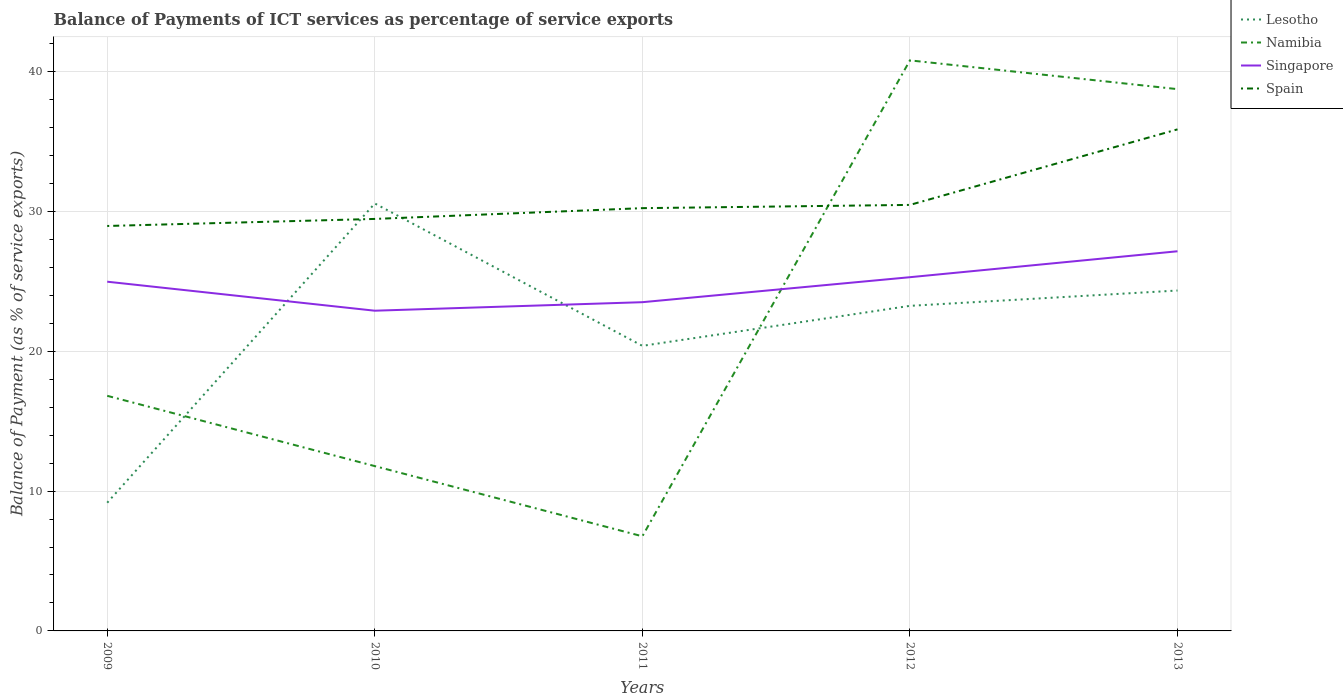How many different coloured lines are there?
Offer a terse response. 4. Does the line corresponding to Namibia intersect with the line corresponding to Singapore?
Make the answer very short. Yes. Across all years, what is the maximum balance of payments of ICT services in Lesotho?
Offer a terse response. 9.17. In which year was the balance of payments of ICT services in Lesotho maximum?
Ensure brevity in your answer.  2009. What is the total balance of payments of ICT services in Spain in the graph?
Keep it short and to the point. -1.51. What is the difference between the highest and the second highest balance of payments of ICT services in Lesotho?
Make the answer very short. 21.4. What is the difference between the highest and the lowest balance of payments of ICT services in Spain?
Make the answer very short. 1. How many lines are there?
Provide a short and direct response. 4. Are the values on the major ticks of Y-axis written in scientific E-notation?
Your answer should be very brief. No. How many legend labels are there?
Offer a terse response. 4. How are the legend labels stacked?
Keep it short and to the point. Vertical. What is the title of the graph?
Offer a terse response. Balance of Payments of ICT services as percentage of service exports. What is the label or title of the X-axis?
Offer a terse response. Years. What is the label or title of the Y-axis?
Your response must be concise. Balance of Payment (as % of service exports). What is the Balance of Payment (as % of service exports) in Lesotho in 2009?
Offer a terse response. 9.17. What is the Balance of Payment (as % of service exports) of Namibia in 2009?
Ensure brevity in your answer.  16.81. What is the Balance of Payment (as % of service exports) of Singapore in 2009?
Give a very brief answer. 24.97. What is the Balance of Payment (as % of service exports) in Spain in 2009?
Offer a very short reply. 28.95. What is the Balance of Payment (as % of service exports) of Lesotho in 2010?
Your answer should be compact. 30.56. What is the Balance of Payment (as % of service exports) in Namibia in 2010?
Ensure brevity in your answer.  11.78. What is the Balance of Payment (as % of service exports) in Singapore in 2010?
Give a very brief answer. 22.9. What is the Balance of Payment (as % of service exports) of Spain in 2010?
Provide a succinct answer. 29.46. What is the Balance of Payment (as % of service exports) of Lesotho in 2011?
Make the answer very short. 20.38. What is the Balance of Payment (as % of service exports) of Namibia in 2011?
Give a very brief answer. 6.77. What is the Balance of Payment (as % of service exports) of Singapore in 2011?
Offer a very short reply. 23.5. What is the Balance of Payment (as % of service exports) in Spain in 2011?
Provide a short and direct response. 30.23. What is the Balance of Payment (as % of service exports) in Lesotho in 2012?
Provide a succinct answer. 23.24. What is the Balance of Payment (as % of service exports) of Namibia in 2012?
Your answer should be compact. 40.79. What is the Balance of Payment (as % of service exports) in Singapore in 2012?
Keep it short and to the point. 25.29. What is the Balance of Payment (as % of service exports) of Spain in 2012?
Offer a terse response. 30.46. What is the Balance of Payment (as % of service exports) in Lesotho in 2013?
Give a very brief answer. 24.34. What is the Balance of Payment (as % of service exports) in Namibia in 2013?
Your answer should be compact. 38.74. What is the Balance of Payment (as % of service exports) of Singapore in 2013?
Your answer should be very brief. 27.15. What is the Balance of Payment (as % of service exports) in Spain in 2013?
Offer a very short reply. 35.86. Across all years, what is the maximum Balance of Payment (as % of service exports) in Lesotho?
Your answer should be very brief. 30.56. Across all years, what is the maximum Balance of Payment (as % of service exports) of Namibia?
Make the answer very short. 40.79. Across all years, what is the maximum Balance of Payment (as % of service exports) in Singapore?
Your answer should be very brief. 27.15. Across all years, what is the maximum Balance of Payment (as % of service exports) in Spain?
Your answer should be very brief. 35.86. Across all years, what is the minimum Balance of Payment (as % of service exports) in Lesotho?
Your answer should be compact. 9.17. Across all years, what is the minimum Balance of Payment (as % of service exports) of Namibia?
Provide a short and direct response. 6.77. Across all years, what is the minimum Balance of Payment (as % of service exports) in Singapore?
Your response must be concise. 22.9. Across all years, what is the minimum Balance of Payment (as % of service exports) in Spain?
Make the answer very short. 28.95. What is the total Balance of Payment (as % of service exports) in Lesotho in the graph?
Ensure brevity in your answer.  107.7. What is the total Balance of Payment (as % of service exports) in Namibia in the graph?
Your response must be concise. 114.89. What is the total Balance of Payment (as % of service exports) in Singapore in the graph?
Your response must be concise. 123.81. What is the total Balance of Payment (as % of service exports) in Spain in the graph?
Ensure brevity in your answer.  154.96. What is the difference between the Balance of Payment (as % of service exports) of Lesotho in 2009 and that in 2010?
Your response must be concise. -21.4. What is the difference between the Balance of Payment (as % of service exports) in Namibia in 2009 and that in 2010?
Keep it short and to the point. 5.03. What is the difference between the Balance of Payment (as % of service exports) of Singapore in 2009 and that in 2010?
Give a very brief answer. 2.07. What is the difference between the Balance of Payment (as % of service exports) of Spain in 2009 and that in 2010?
Make the answer very short. -0.5. What is the difference between the Balance of Payment (as % of service exports) in Lesotho in 2009 and that in 2011?
Ensure brevity in your answer.  -11.22. What is the difference between the Balance of Payment (as % of service exports) of Namibia in 2009 and that in 2011?
Offer a very short reply. 10.05. What is the difference between the Balance of Payment (as % of service exports) of Singapore in 2009 and that in 2011?
Your answer should be very brief. 1.47. What is the difference between the Balance of Payment (as % of service exports) of Spain in 2009 and that in 2011?
Provide a succinct answer. -1.27. What is the difference between the Balance of Payment (as % of service exports) of Lesotho in 2009 and that in 2012?
Provide a short and direct response. -14.08. What is the difference between the Balance of Payment (as % of service exports) in Namibia in 2009 and that in 2012?
Offer a terse response. -23.98. What is the difference between the Balance of Payment (as % of service exports) of Singapore in 2009 and that in 2012?
Give a very brief answer. -0.32. What is the difference between the Balance of Payment (as % of service exports) in Spain in 2009 and that in 2012?
Provide a short and direct response. -1.51. What is the difference between the Balance of Payment (as % of service exports) in Lesotho in 2009 and that in 2013?
Give a very brief answer. -15.17. What is the difference between the Balance of Payment (as % of service exports) of Namibia in 2009 and that in 2013?
Make the answer very short. -21.93. What is the difference between the Balance of Payment (as % of service exports) in Singapore in 2009 and that in 2013?
Provide a succinct answer. -2.18. What is the difference between the Balance of Payment (as % of service exports) of Spain in 2009 and that in 2013?
Keep it short and to the point. -6.91. What is the difference between the Balance of Payment (as % of service exports) of Lesotho in 2010 and that in 2011?
Offer a terse response. 10.18. What is the difference between the Balance of Payment (as % of service exports) of Namibia in 2010 and that in 2011?
Offer a terse response. 5.02. What is the difference between the Balance of Payment (as % of service exports) of Singapore in 2010 and that in 2011?
Your answer should be compact. -0.61. What is the difference between the Balance of Payment (as % of service exports) of Spain in 2010 and that in 2011?
Your response must be concise. -0.77. What is the difference between the Balance of Payment (as % of service exports) of Lesotho in 2010 and that in 2012?
Provide a short and direct response. 7.32. What is the difference between the Balance of Payment (as % of service exports) of Namibia in 2010 and that in 2012?
Give a very brief answer. -29.01. What is the difference between the Balance of Payment (as % of service exports) of Singapore in 2010 and that in 2012?
Give a very brief answer. -2.4. What is the difference between the Balance of Payment (as % of service exports) of Spain in 2010 and that in 2012?
Provide a succinct answer. -1. What is the difference between the Balance of Payment (as % of service exports) of Lesotho in 2010 and that in 2013?
Your answer should be compact. 6.22. What is the difference between the Balance of Payment (as % of service exports) of Namibia in 2010 and that in 2013?
Offer a terse response. -26.95. What is the difference between the Balance of Payment (as % of service exports) of Singapore in 2010 and that in 2013?
Your answer should be compact. -4.25. What is the difference between the Balance of Payment (as % of service exports) in Spain in 2010 and that in 2013?
Make the answer very short. -6.4. What is the difference between the Balance of Payment (as % of service exports) of Lesotho in 2011 and that in 2012?
Offer a very short reply. -2.86. What is the difference between the Balance of Payment (as % of service exports) in Namibia in 2011 and that in 2012?
Your response must be concise. -34.03. What is the difference between the Balance of Payment (as % of service exports) of Singapore in 2011 and that in 2012?
Make the answer very short. -1.79. What is the difference between the Balance of Payment (as % of service exports) in Spain in 2011 and that in 2012?
Give a very brief answer. -0.23. What is the difference between the Balance of Payment (as % of service exports) in Lesotho in 2011 and that in 2013?
Ensure brevity in your answer.  -3.96. What is the difference between the Balance of Payment (as % of service exports) in Namibia in 2011 and that in 2013?
Provide a succinct answer. -31.97. What is the difference between the Balance of Payment (as % of service exports) in Singapore in 2011 and that in 2013?
Your response must be concise. -3.64. What is the difference between the Balance of Payment (as % of service exports) of Spain in 2011 and that in 2013?
Provide a short and direct response. -5.63. What is the difference between the Balance of Payment (as % of service exports) of Lesotho in 2012 and that in 2013?
Ensure brevity in your answer.  -1.1. What is the difference between the Balance of Payment (as % of service exports) in Namibia in 2012 and that in 2013?
Your answer should be compact. 2.06. What is the difference between the Balance of Payment (as % of service exports) in Singapore in 2012 and that in 2013?
Make the answer very short. -1.85. What is the difference between the Balance of Payment (as % of service exports) in Spain in 2012 and that in 2013?
Make the answer very short. -5.4. What is the difference between the Balance of Payment (as % of service exports) of Lesotho in 2009 and the Balance of Payment (as % of service exports) of Namibia in 2010?
Give a very brief answer. -2.62. What is the difference between the Balance of Payment (as % of service exports) of Lesotho in 2009 and the Balance of Payment (as % of service exports) of Singapore in 2010?
Provide a short and direct response. -13.73. What is the difference between the Balance of Payment (as % of service exports) in Lesotho in 2009 and the Balance of Payment (as % of service exports) in Spain in 2010?
Provide a succinct answer. -20.29. What is the difference between the Balance of Payment (as % of service exports) of Namibia in 2009 and the Balance of Payment (as % of service exports) of Singapore in 2010?
Your answer should be compact. -6.08. What is the difference between the Balance of Payment (as % of service exports) of Namibia in 2009 and the Balance of Payment (as % of service exports) of Spain in 2010?
Offer a terse response. -12.65. What is the difference between the Balance of Payment (as % of service exports) in Singapore in 2009 and the Balance of Payment (as % of service exports) in Spain in 2010?
Keep it short and to the point. -4.49. What is the difference between the Balance of Payment (as % of service exports) of Lesotho in 2009 and the Balance of Payment (as % of service exports) of Namibia in 2011?
Offer a very short reply. 2.4. What is the difference between the Balance of Payment (as % of service exports) of Lesotho in 2009 and the Balance of Payment (as % of service exports) of Singapore in 2011?
Provide a succinct answer. -14.34. What is the difference between the Balance of Payment (as % of service exports) in Lesotho in 2009 and the Balance of Payment (as % of service exports) in Spain in 2011?
Ensure brevity in your answer.  -21.06. What is the difference between the Balance of Payment (as % of service exports) in Namibia in 2009 and the Balance of Payment (as % of service exports) in Singapore in 2011?
Ensure brevity in your answer.  -6.69. What is the difference between the Balance of Payment (as % of service exports) of Namibia in 2009 and the Balance of Payment (as % of service exports) of Spain in 2011?
Make the answer very short. -13.42. What is the difference between the Balance of Payment (as % of service exports) in Singapore in 2009 and the Balance of Payment (as % of service exports) in Spain in 2011?
Your answer should be compact. -5.26. What is the difference between the Balance of Payment (as % of service exports) in Lesotho in 2009 and the Balance of Payment (as % of service exports) in Namibia in 2012?
Your answer should be very brief. -31.63. What is the difference between the Balance of Payment (as % of service exports) in Lesotho in 2009 and the Balance of Payment (as % of service exports) in Singapore in 2012?
Keep it short and to the point. -16.13. What is the difference between the Balance of Payment (as % of service exports) in Lesotho in 2009 and the Balance of Payment (as % of service exports) in Spain in 2012?
Ensure brevity in your answer.  -21.29. What is the difference between the Balance of Payment (as % of service exports) in Namibia in 2009 and the Balance of Payment (as % of service exports) in Singapore in 2012?
Make the answer very short. -8.48. What is the difference between the Balance of Payment (as % of service exports) of Namibia in 2009 and the Balance of Payment (as % of service exports) of Spain in 2012?
Your answer should be very brief. -13.65. What is the difference between the Balance of Payment (as % of service exports) of Singapore in 2009 and the Balance of Payment (as % of service exports) of Spain in 2012?
Give a very brief answer. -5.49. What is the difference between the Balance of Payment (as % of service exports) of Lesotho in 2009 and the Balance of Payment (as % of service exports) of Namibia in 2013?
Your answer should be very brief. -29.57. What is the difference between the Balance of Payment (as % of service exports) in Lesotho in 2009 and the Balance of Payment (as % of service exports) in Singapore in 2013?
Your answer should be compact. -17.98. What is the difference between the Balance of Payment (as % of service exports) of Lesotho in 2009 and the Balance of Payment (as % of service exports) of Spain in 2013?
Your response must be concise. -26.7. What is the difference between the Balance of Payment (as % of service exports) in Namibia in 2009 and the Balance of Payment (as % of service exports) in Singapore in 2013?
Provide a succinct answer. -10.33. What is the difference between the Balance of Payment (as % of service exports) of Namibia in 2009 and the Balance of Payment (as % of service exports) of Spain in 2013?
Offer a terse response. -19.05. What is the difference between the Balance of Payment (as % of service exports) in Singapore in 2009 and the Balance of Payment (as % of service exports) in Spain in 2013?
Your answer should be very brief. -10.89. What is the difference between the Balance of Payment (as % of service exports) of Lesotho in 2010 and the Balance of Payment (as % of service exports) of Namibia in 2011?
Your answer should be very brief. 23.8. What is the difference between the Balance of Payment (as % of service exports) in Lesotho in 2010 and the Balance of Payment (as % of service exports) in Singapore in 2011?
Offer a terse response. 7.06. What is the difference between the Balance of Payment (as % of service exports) of Lesotho in 2010 and the Balance of Payment (as % of service exports) of Spain in 2011?
Give a very brief answer. 0.34. What is the difference between the Balance of Payment (as % of service exports) in Namibia in 2010 and the Balance of Payment (as % of service exports) in Singapore in 2011?
Make the answer very short. -11.72. What is the difference between the Balance of Payment (as % of service exports) of Namibia in 2010 and the Balance of Payment (as % of service exports) of Spain in 2011?
Give a very brief answer. -18.44. What is the difference between the Balance of Payment (as % of service exports) in Singapore in 2010 and the Balance of Payment (as % of service exports) in Spain in 2011?
Offer a terse response. -7.33. What is the difference between the Balance of Payment (as % of service exports) of Lesotho in 2010 and the Balance of Payment (as % of service exports) of Namibia in 2012?
Provide a succinct answer. -10.23. What is the difference between the Balance of Payment (as % of service exports) in Lesotho in 2010 and the Balance of Payment (as % of service exports) in Singapore in 2012?
Ensure brevity in your answer.  5.27. What is the difference between the Balance of Payment (as % of service exports) of Lesotho in 2010 and the Balance of Payment (as % of service exports) of Spain in 2012?
Ensure brevity in your answer.  0.1. What is the difference between the Balance of Payment (as % of service exports) in Namibia in 2010 and the Balance of Payment (as % of service exports) in Singapore in 2012?
Ensure brevity in your answer.  -13.51. What is the difference between the Balance of Payment (as % of service exports) of Namibia in 2010 and the Balance of Payment (as % of service exports) of Spain in 2012?
Offer a very short reply. -18.68. What is the difference between the Balance of Payment (as % of service exports) in Singapore in 2010 and the Balance of Payment (as % of service exports) in Spain in 2012?
Your response must be concise. -7.57. What is the difference between the Balance of Payment (as % of service exports) in Lesotho in 2010 and the Balance of Payment (as % of service exports) in Namibia in 2013?
Your answer should be compact. -8.17. What is the difference between the Balance of Payment (as % of service exports) of Lesotho in 2010 and the Balance of Payment (as % of service exports) of Singapore in 2013?
Make the answer very short. 3.42. What is the difference between the Balance of Payment (as % of service exports) of Lesotho in 2010 and the Balance of Payment (as % of service exports) of Spain in 2013?
Provide a short and direct response. -5.3. What is the difference between the Balance of Payment (as % of service exports) of Namibia in 2010 and the Balance of Payment (as % of service exports) of Singapore in 2013?
Keep it short and to the point. -15.36. What is the difference between the Balance of Payment (as % of service exports) in Namibia in 2010 and the Balance of Payment (as % of service exports) in Spain in 2013?
Give a very brief answer. -24.08. What is the difference between the Balance of Payment (as % of service exports) of Singapore in 2010 and the Balance of Payment (as % of service exports) of Spain in 2013?
Offer a terse response. -12.97. What is the difference between the Balance of Payment (as % of service exports) of Lesotho in 2011 and the Balance of Payment (as % of service exports) of Namibia in 2012?
Offer a terse response. -20.41. What is the difference between the Balance of Payment (as % of service exports) in Lesotho in 2011 and the Balance of Payment (as % of service exports) in Singapore in 2012?
Offer a very short reply. -4.91. What is the difference between the Balance of Payment (as % of service exports) in Lesotho in 2011 and the Balance of Payment (as % of service exports) in Spain in 2012?
Your response must be concise. -10.08. What is the difference between the Balance of Payment (as % of service exports) in Namibia in 2011 and the Balance of Payment (as % of service exports) in Singapore in 2012?
Give a very brief answer. -18.53. What is the difference between the Balance of Payment (as % of service exports) in Namibia in 2011 and the Balance of Payment (as % of service exports) in Spain in 2012?
Offer a terse response. -23.7. What is the difference between the Balance of Payment (as % of service exports) in Singapore in 2011 and the Balance of Payment (as % of service exports) in Spain in 2012?
Your answer should be very brief. -6.96. What is the difference between the Balance of Payment (as % of service exports) of Lesotho in 2011 and the Balance of Payment (as % of service exports) of Namibia in 2013?
Give a very brief answer. -18.35. What is the difference between the Balance of Payment (as % of service exports) in Lesotho in 2011 and the Balance of Payment (as % of service exports) in Singapore in 2013?
Make the answer very short. -6.76. What is the difference between the Balance of Payment (as % of service exports) of Lesotho in 2011 and the Balance of Payment (as % of service exports) of Spain in 2013?
Give a very brief answer. -15.48. What is the difference between the Balance of Payment (as % of service exports) in Namibia in 2011 and the Balance of Payment (as % of service exports) in Singapore in 2013?
Offer a very short reply. -20.38. What is the difference between the Balance of Payment (as % of service exports) of Namibia in 2011 and the Balance of Payment (as % of service exports) of Spain in 2013?
Give a very brief answer. -29.1. What is the difference between the Balance of Payment (as % of service exports) in Singapore in 2011 and the Balance of Payment (as % of service exports) in Spain in 2013?
Keep it short and to the point. -12.36. What is the difference between the Balance of Payment (as % of service exports) of Lesotho in 2012 and the Balance of Payment (as % of service exports) of Namibia in 2013?
Provide a short and direct response. -15.49. What is the difference between the Balance of Payment (as % of service exports) in Lesotho in 2012 and the Balance of Payment (as % of service exports) in Singapore in 2013?
Your response must be concise. -3.9. What is the difference between the Balance of Payment (as % of service exports) of Lesotho in 2012 and the Balance of Payment (as % of service exports) of Spain in 2013?
Your answer should be very brief. -12.62. What is the difference between the Balance of Payment (as % of service exports) in Namibia in 2012 and the Balance of Payment (as % of service exports) in Singapore in 2013?
Keep it short and to the point. 13.65. What is the difference between the Balance of Payment (as % of service exports) in Namibia in 2012 and the Balance of Payment (as % of service exports) in Spain in 2013?
Offer a very short reply. 4.93. What is the difference between the Balance of Payment (as % of service exports) of Singapore in 2012 and the Balance of Payment (as % of service exports) of Spain in 2013?
Keep it short and to the point. -10.57. What is the average Balance of Payment (as % of service exports) of Lesotho per year?
Offer a terse response. 21.54. What is the average Balance of Payment (as % of service exports) in Namibia per year?
Ensure brevity in your answer.  22.98. What is the average Balance of Payment (as % of service exports) in Singapore per year?
Offer a very short reply. 24.76. What is the average Balance of Payment (as % of service exports) in Spain per year?
Give a very brief answer. 30.99. In the year 2009, what is the difference between the Balance of Payment (as % of service exports) of Lesotho and Balance of Payment (as % of service exports) of Namibia?
Provide a short and direct response. -7.64. In the year 2009, what is the difference between the Balance of Payment (as % of service exports) of Lesotho and Balance of Payment (as % of service exports) of Singapore?
Offer a very short reply. -15.8. In the year 2009, what is the difference between the Balance of Payment (as % of service exports) in Lesotho and Balance of Payment (as % of service exports) in Spain?
Your response must be concise. -19.79. In the year 2009, what is the difference between the Balance of Payment (as % of service exports) of Namibia and Balance of Payment (as % of service exports) of Singapore?
Offer a very short reply. -8.16. In the year 2009, what is the difference between the Balance of Payment (as % of service exports) in Namibia and Balance of Payment (as % of service exports) in Spain?
Ensure brevity in your answer.  -12.14. In the year 2009, what is the difference between the Balance of Payment (as % of service exports) of Singapore and Balance of Payment (as % of service exports) of Spain?
Provide a short and direct response. -3.98. In the year 2010, what is the difference between the Balance of Payment (as % of service exports) of Lesotho and Balance of Payment (as % of service exports) of Namibia?
Keep it short and to the point. 18.78. In the year 2010, what is the difference between the Balance of Payment (as % of service exports) in Lesotho and Balance of Payment (as % of service exports) in Singapore?
Your response must be concise. 7.67. In the year 2010, what is the difference between the Balance of Payment (as % of service exports) in Lesotho and Balance of Payment (as % of service exports) in Spain?
Make the answer very short. 1.11. In the year 2010, what is the difference between the Balance of Payment (as % of service exports) of Namibia and Balance of Payment (as % of service exports) of Singapore?
Ensure brevity in your answer.  -11.11. In the year 2010, what is the difference between the Balance of Payment (as % of service exports) in Namibia and Balance of Payment (as % of service exports) in Spain?
Offer a terse response. -17.67. In the year 2010, what is the difference between the Balance of Payment (as % of service exports) in Singapore and Balance of Payment (as % of service exports) in Spain?
Offer a terse response. -6.56. In the year 2011, what is the difference between the Balance of Payment (as % of service exports) in Lesotho and Balance of Payment (as % of service exports) in Namibia?
Keep it short and to the point. 13.62. In the year 2011, what is the difference between the Balance of Payment (as % of service exports) of Lesotho and Balance of Payment (as % of service exports) of Singapore?
Your response must be concise. -3.12. In the year 2011, what is the difference between the Balance of Payment (as % of service exports) of Lesotho and Balance of Payment (as % of service exports) of Spain?
Your answer should be very brief. -9.85. In the year 2011, what is the difference between the Balance of Payment (as % of service exports) in Namibia and Balance of Payment (as % of service exports) in Singapore?
Keep it short and to the point. -16.74. In the year 2011, what is the difference between the Balance of Payment (as % of service exports) of Namibia and Balance of Payment (as % of service exports) of Spain?
Give a very brief answer. -23.46. In the year 2011, what is the difference between the Balance of Payment (as % of service exports) of Singapore and Balance of Payment (as % of service exports) of Spain?
Keep it short and to the point. -6.72. In the year 2012, what is the difference between the Balance of Payment (as % of service exports) of Lesotho and Balance of Payment (as % of service exports) of Namibia?
Make the answer very short. -17.55. In the year 2012, what is the difference between the Balance of Payment (as % of service exports) of Lesotho and Balance of Payment (as % of service exports) of Singapore?
Keep it short and to the point. -2.05. In the year 2012, what is the difference between the Balance of Payment (as % of service exports) in Lesotho and Balance of Payment (as % of service exports) in Spain?
Keep it short and to the point. -7.22. In the year 2012, what is the difference between the Balance of Payment (as % of service exports) in Namibia and Balance of Payment (as % of service exports) in Singapore?
Provide a succinct answer. 15.5. In the year 2012, what is the difference between the Balance of Payment (as % of service exports) of Namibia and Balance of Payment (as % of service exports) of Spain?
Offer a very short reply. 10.33. In the year 2012, what is the difference between the Balance of Payment (as % of service exports) in Singapore and Balance of Payment (as % of service exports) in Spain?
Give a very brief answer. -5.17. In the year 2013, what is the difference between the Balance of Payment (as % of service exports) of Lesotho and Balance of Payment (as % of service exports) of Namibia?
Your answer should be very brief. -14.4. In the year 2013, what is the difference between the Balance of Payment (as % of service exports) in Lesotho and Balance of Payment (as % of service exports) in Singapore?
Offer a terse response. -2.81. In the year 2013, what is the difference between the Balance of Payment (as % of service exports) of Lesotho and Balance of Payment (as % of service exports) of Spain?
Make the answer very short. -11.52. In the year 2013, what is the difference between the Balance of Payment (as % of service exports) in Namibia and Balance of Payment (as % of service exports) in Singapore?
Your answer should be very brief. 11.59. In the year 2013, what is the difference between the Balance of Payment (as % of service exports) of Namibia and Balance of Payment (as % of service exports) of Spain?
Provide a succinct answer. 2.88. In the year 2013, what is the difference between the Balance of Payment (as % of service exports) of Singapore and Balance of Payment (as % of service exports) of Spain?
Offer a very short reply. -8.72. What is the ratio of the Balance of Payment (as % of service exports) in Lesotho in 2009 to that in 2010?
Provide a short and direct response. 0.3. What is the ratio of the Balance of Payment (as % of service exports) in Namibia in 2009 to that in 2010?
Your answer should be compact. 1.43. What is the ratio of the Balance of Payment (as % of service exports) of Singapore in 2009 to that in 2010?
Your response must be concise. 1.09. What is the ratio of the Balance of Payment (as % of service exports) in Spain in 2009 to that in 2010?
Ensure brevity in your answer.  0.98. What is the ratio of the Balance of Payment (as % of service exports) in Lesotho in 2009 to that in 2011?
Give a very brief answer. 0.45. What is the ratio of the Balance of Payment (as % of service exports) of Namibia in 2009 to that in 2011?
Offer a very short reply. 2.48. What is the ratio of the Balance of Payment (as % of service exports) of Singapore in 2009 to that in 2011?
Offer a terse response. 1.06. What is the ratio of the Balance of Payment (as % of service exports) in Spain in 2009 to that in 2011?
Offer a very short reply. 0.96. What is the ratio of the Balance of Payment (as % of service exports) in Lesotho in 2009 to that in 2012?
Keep it short and to the point. 0.39. What is the ratio of the Balance of Payment (as % of service exports) in Namibia in 2009 to that in 2012?
Offer a very short reply. 0.41. What is the ratio of the Balance of Payment (as % of service exports) of Singapore in 2009 to that in 2012?
Your answer should be very brief. 0.99. What is the ratio of the Balance of Payment (as % of service exports) of Spain in 2009 to that in 2012?
Provide a short and direct response. 0.95. What is the ratio of the Balance of Payment (as % of service exports) of Lesotho in 2009 to that in 2013?
Provide a succinct answer. 0.38. What is the ratio of the Balance of Payment (as % of service exports) of Namibia in 2009 to that in 2013?
Make the answer very short. 0.43. What is the ratio of the Balance of Payment (as % of service exports) in Singapore in 2009 to that in 2013?
Offer a terse response. 0.92. What is the ratio of the Balance of Payment (as % of service exports) of Spain in 2009 to that in 2013?
Give a very brief answer. 0.81. What is the ratio of the Balance of Payment (as % of service exports) in Lesotho in 2010 to that in 2011?
Your answer should be compact. 1.5. What is the ratio of the Balance of Payment (as % of service exports) in Namibia in 2010 to that in 2011?
Your answer should be very brief. 1.74. What is the ratio of the Balance of Payment (as % of service exports) in Singapore in 2010 to that in 2011?
Your response must be concise. 0.97. What is the ratio of the Balance of Payment (as % of service exports) in Spain in 2010 to that in 2011?
Provide a short and direct response. 0.97. What is the ratio of the Balance of Payment (as % of service exports) in Lesotho in 2010 to that in 2012?
Provide a short and direct response. 1.31. What is the ratio of the Balance of Payment (as % of service exports) in Namibia in 2010 to that in 2012?
Your answer should be very brief. 0.29. What is the ratio of the Balance of Payment (as % of service exports) of Singapore in 2010 to that in 2012?
Ensure brevity in your answer.  0.91. What is the ratio of the Balance of Payment (as % of service exports) in Spain in 2010 to that in 2012?
Offer a very short reply. 0.97. What is the ratio of the Balance of Payment (as % of service exports) in Lesotho in 2010 to that in 2013?
Provide a short and direct response. 1.26. What is the ratio of the Balance of Payment (as % of service exports) of Namibia in 2010 to that in 2013?
Offer a terse response. 0.3. What is the ratio of the Balance of Payment (as % of service exports) in Singapore in 2010 to that in 2013?
Provide a short and direct response. 0.84. What is the ratio of the Balance of Payment (as % of service exports) of Spain in 2010 to that in 2013?
Keep it short and to the point. 0.82. What is the ratio of the Balance of Payment (as % of service exports) in Lesotho in 2011 to that in 2012?
Your answer should be compact. 0.88. What is the ratio of the Balance of Payment (as % of service exports) of Namibia in 2011 to that in 2012?
Ensure brevity in your answer.  0.17. What is the ratio of the Balance of Payment (as % of service exports) of Singapore in 2011 to that in 2012?
Ensure brevity in your answer.  0.93. What is the ratio of the Balance of Payment (as % of service exports) of Lesotho in 2011 to that in 2013?
Your answer should be compact. 0.84. What is the ratio of the Balance of Payment (as % of service exports) of Namibia in 2011 to that in 2013?
Your answer should be very brief. 0.17. What is the ratio of the Balance of Payment (as % of service exports) in Singapore in 2011 to that in 2013?
Ensure brevity in your answer.  0.87. What is the ratio of the Balance of Payment (as % of service exports) in Spain in 2011 to that in 2013?
Give a very brief answer. 0.84. What is the ratio of the Balance of Payment (as % of service exports) in Lesotho in 2012 to that in 2013?
Your answer should be very brief. 0.95. What is the ratio of the Balance of Payment (as % of service exports) of Namibia in 2012 to that in 2013?
Ensure brevity in your answer.  1.05. What is the ratio of the Balance of Payment (as % of service exports) in Singapore in 2012 to that in 2013?
Make the answer very short. 0.93. What is the ratio of the Balance of Payment (as % of service exports) in Spain in 2012 to that in 2013?
Keep it short and to the point. 0.85. What is the difference between the highest and the second highest Balance of Payment (as % of service exports) of Lesotho?
Your answer should be compact. 6.22. What is the difference between the highest and the second highest Balance of Payment (as % of service exports) of Namibia?
Provide a short and direct response. 2.06. What is the difference between the highest and the second highest Balance of Payment (as % of service exports) in Singapore?
Your response must be concise. 1.85. What is the difference between the highest and the second highest Balance of Payment (as % of service exports) of Spain?
Give a very brief answer. 5.4. What is the difference between the highest and the lowest Balance of Payment (as % of service exports) of Lesotho?
Your response must be concise. 21.4. What is the difference between the highest and the lowest Balance of Payment (as % of service exports) in Namibia?
Your response must be concise. 34.03. What is the difference between the highest and the lowest Balance of Payment (as % of service exports) of Singapore?
Ensure brevity in your answer.  4.25. What is the difference between the highest and the lowest Balance of Payment (as % of service exports) in Spain?
Keep it short and to the point. 6.91. 